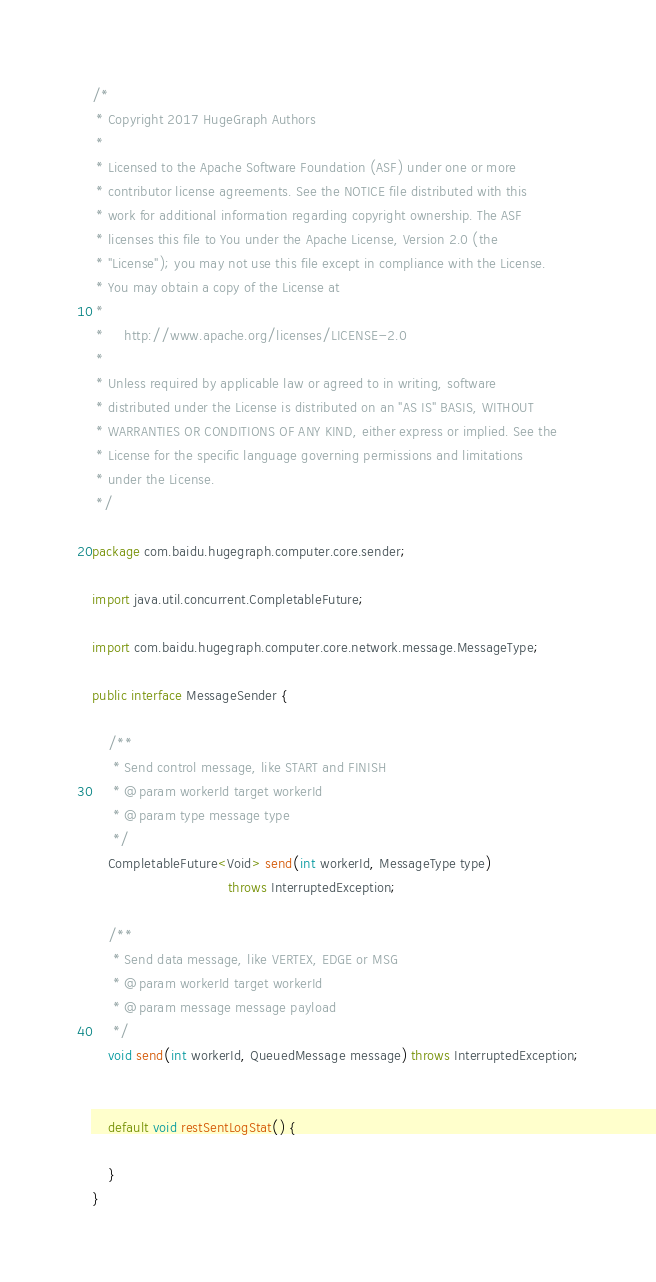Convert code to text. <code><loc_0><loc_0><loc_500><loc_500><_Java_>/*
 * Copyright 2017 HugeGraph Authors
 *
 * Licensed to the Apache Software Foundation (ASF) under one or more
 * contributor license agreements. See the NOTICE file distributed with this
 * work for additional information regarding copyright ownership. The ASF
 * licenses this file to You under the Apache License, Version 2.0 (the
 * "License"); you may not use this file except in compliance with the License.
 * You may obtain a copy of the License at
 *
 *     http://www.apache.org/licenses/LICENSE-2.0
 *
 * Unless required by applicable law or agreed to in writing, software
 * distributed under the License is distributed on an "AS IS" BASIS, WITHOUT
 * WARRANTIES OR CONDITIONS OF ANY KIND, either express or implied. See the
 * License for the specific language governing permissions and limitations
 * under the License.
 */

package com.baidu.hugegraph.computer.core.sender;

import java.util.concurrent.CompletableFuture;

import com.baidu.hugegraph.computer.core.network.message.MessageType;

public interface MessageSender {

    /**
     * Send control message, like START and FINISH
     * @param workerId target workerId
     * @param type message type
     */
    CompletableFuture<Void> send(int workerId, MessageType type)
                                 throws InterruptedException;

    /**
     * Send data message, like VERTEX, EDGE or MSG
     * @param workerId target workerId
     * @param message message payload
     */
    void send(int workerId, QueuedMessage message) throws InterruptedException;


    default void restSentLogStat() {

    }
}
</code> 